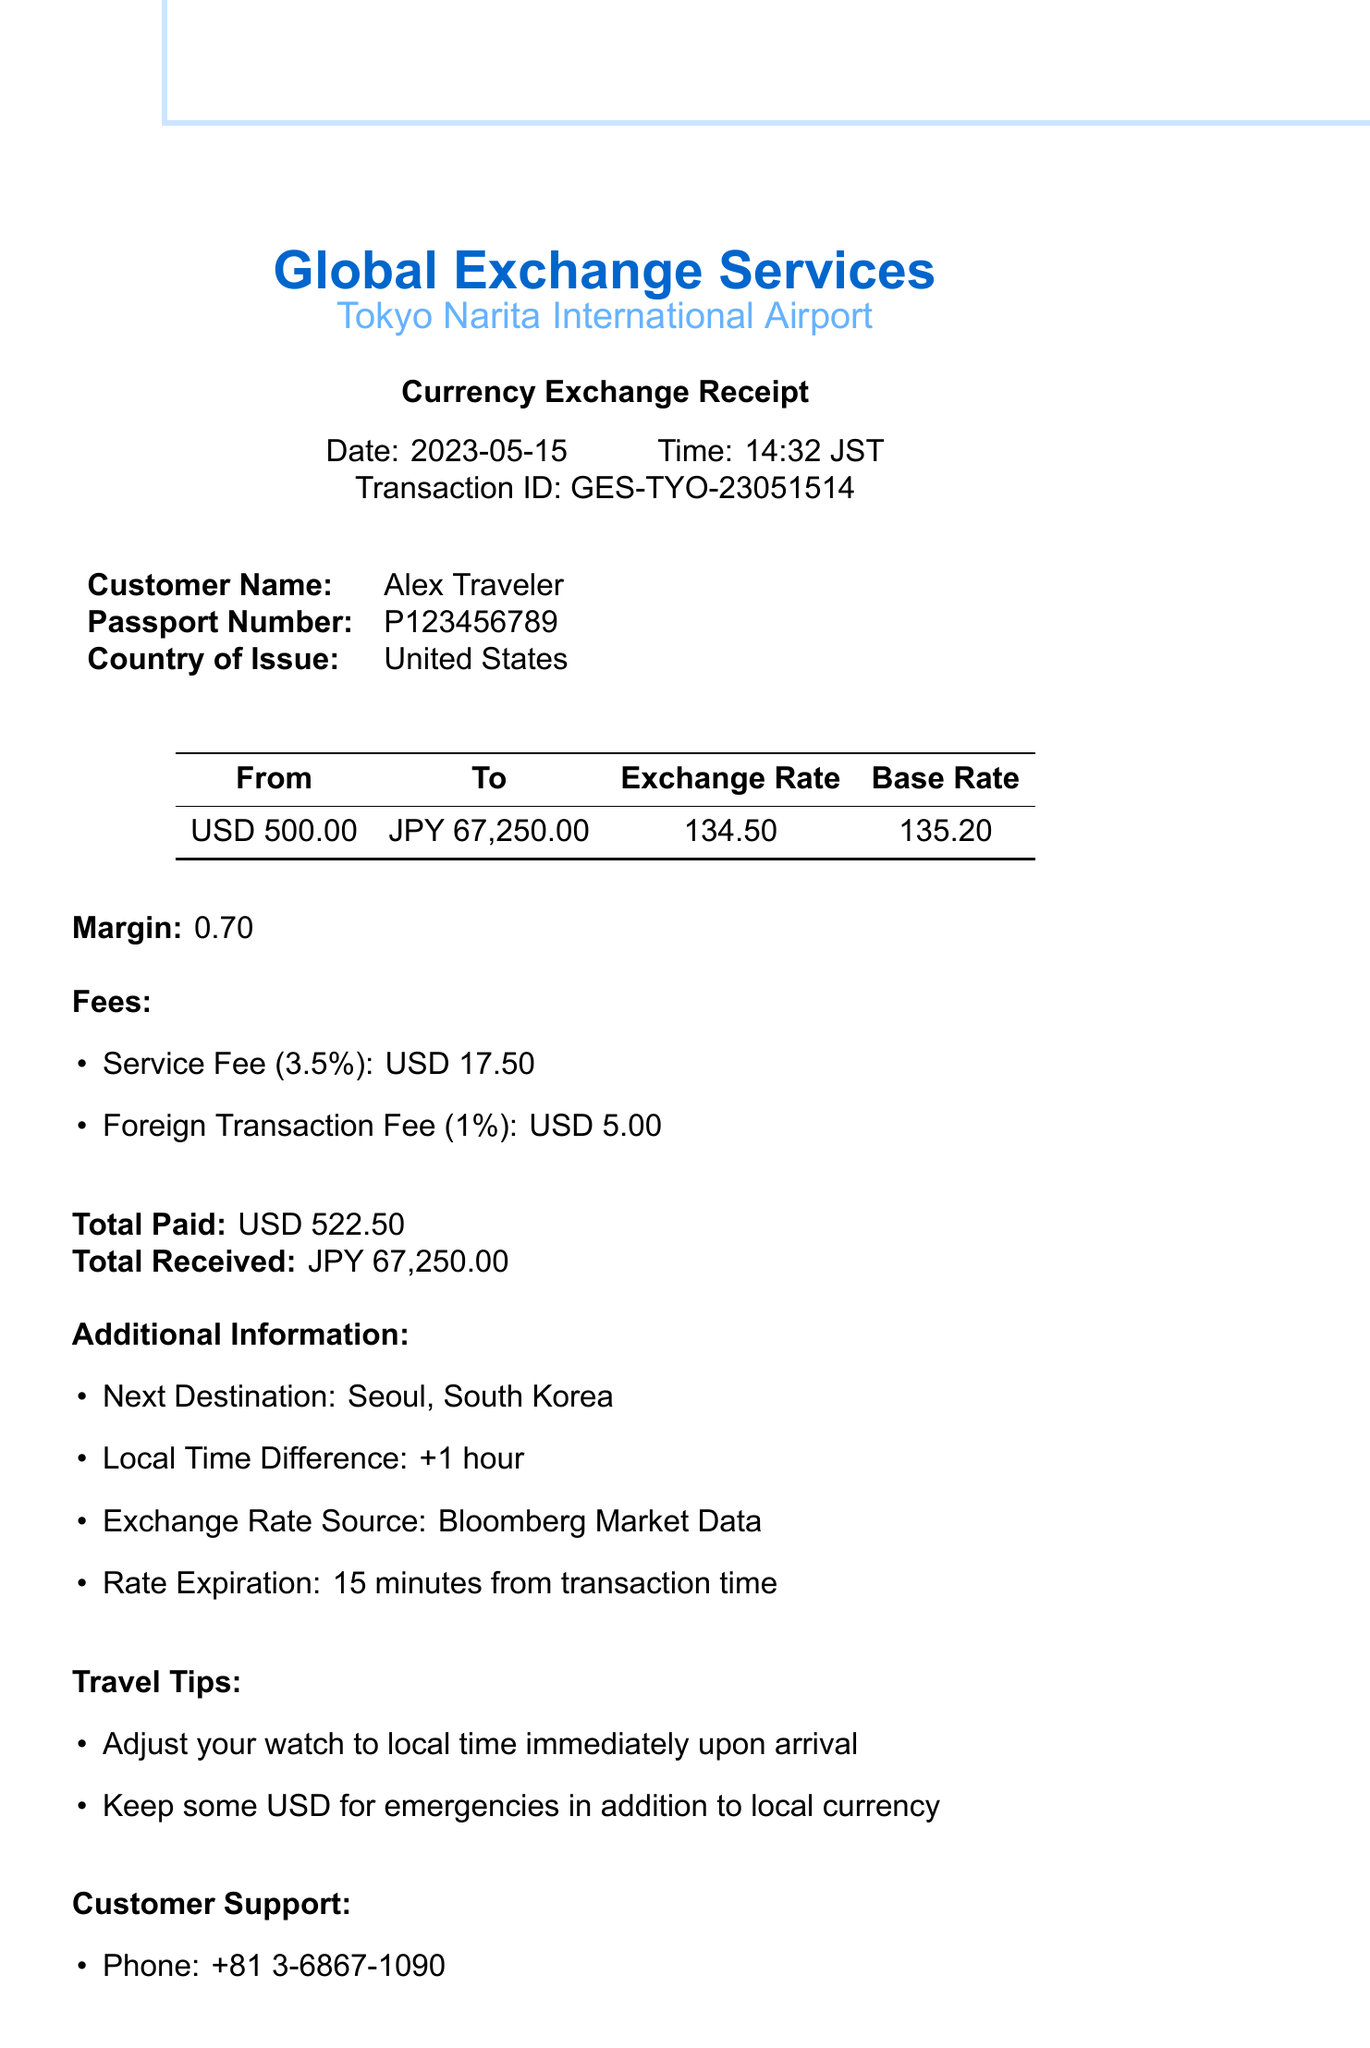What is the company name? The company name is specified in the header of the receipt, which is Global Exchange Services.
Answer: Global Exchange Services What is the exchange rate? The exchange rate is listed in the exchange details section, indicating how much JPY one USD is worth.
Answer: 134.50 What is the amount received in JPY? The total amount received is detailed in the exchange details, showing the equivalent value of the exchanged currency.
Answer: 67,250.00 What is the total paid in USD? The total paid is highlighted at the end of the receipt, representing the total amount the customer exchanged.
Answer: 522.50 What is the service fee amount? The service fee is listed under fees, specifying the dollar amount charged for the service provided by the exchange.
Answer: 17.50 How long is the exchange rate valid? The expiration of the exchange rate is mentioned in the additional information section, indicating how long the rate can be used after the transaction.
Answer: 15 minutes Which country will the customer travel to next? The next destination is included in the additional information, specifying where the traveler intends to go next.
Answer: Seoul, South Korea What was the margin percentage applied to the exchange? The margin percentage is mentioned in the exchange details and shows how much extra the exchange service charged beyond the base rate.
Answer: 0.70 What is the legal disclaimer regarding exchange rates? The legal disclaimer explains the risks associated with currency exchange and the company's liability, which is noted at the bottom of the document.
Answer: Exchange rates are subject to market fluctuations 